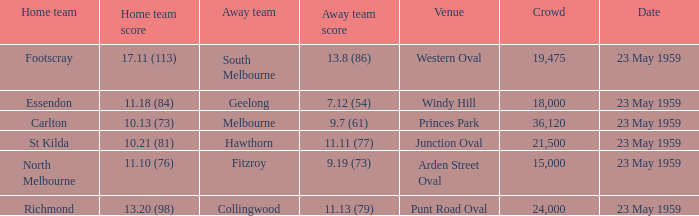What was the local team's score at the event taking place at punt road oval? 13.20 (98). 